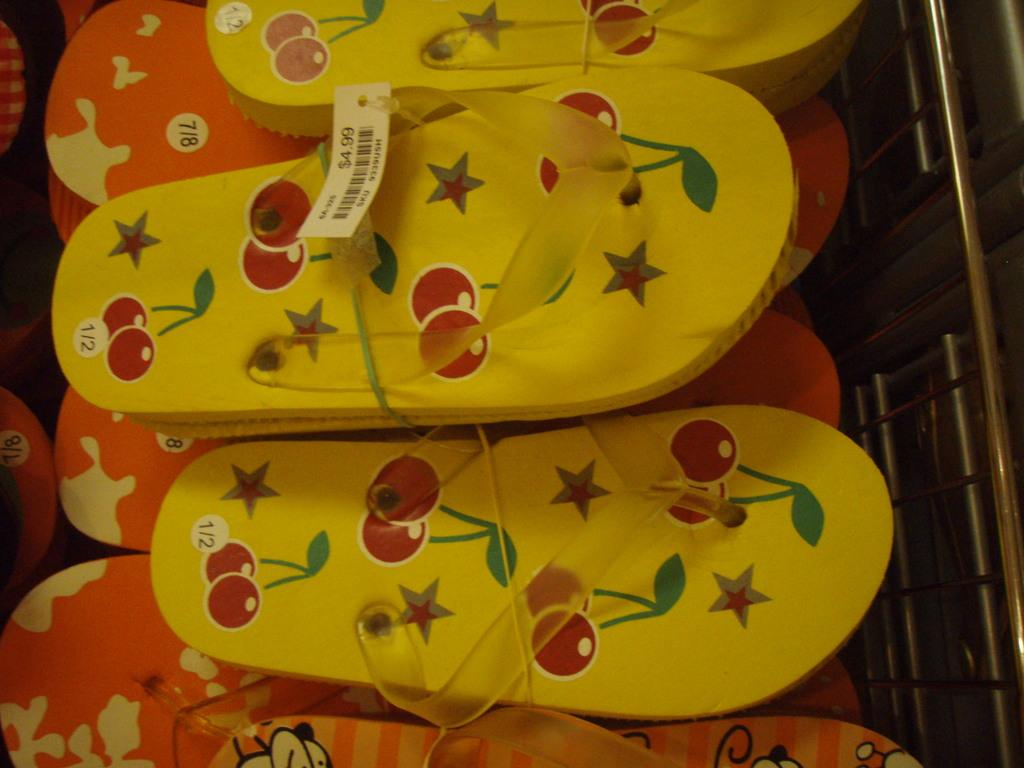What type of footwear can be seen in the image? There are a few pairs of slippers in the image. How are the slippers organized in the image? The slippers are arranged in a rack. What type of boat is visible in the image? There is no boat present in the image; it features a few pairs of slippers arranged in a rack. What ideas can be generated from the list of slippers in the image? There is no list of slippers in the image, only a few pairs arranged in a rack. 